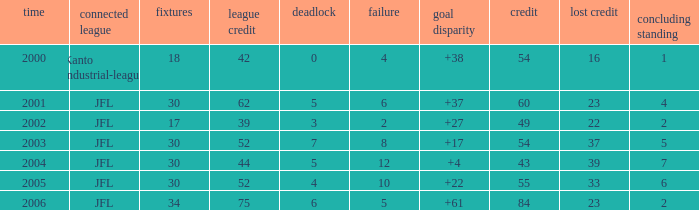I want the average lose for lost point more than 16 and goal difference less than 37 and point less than 43 None. 